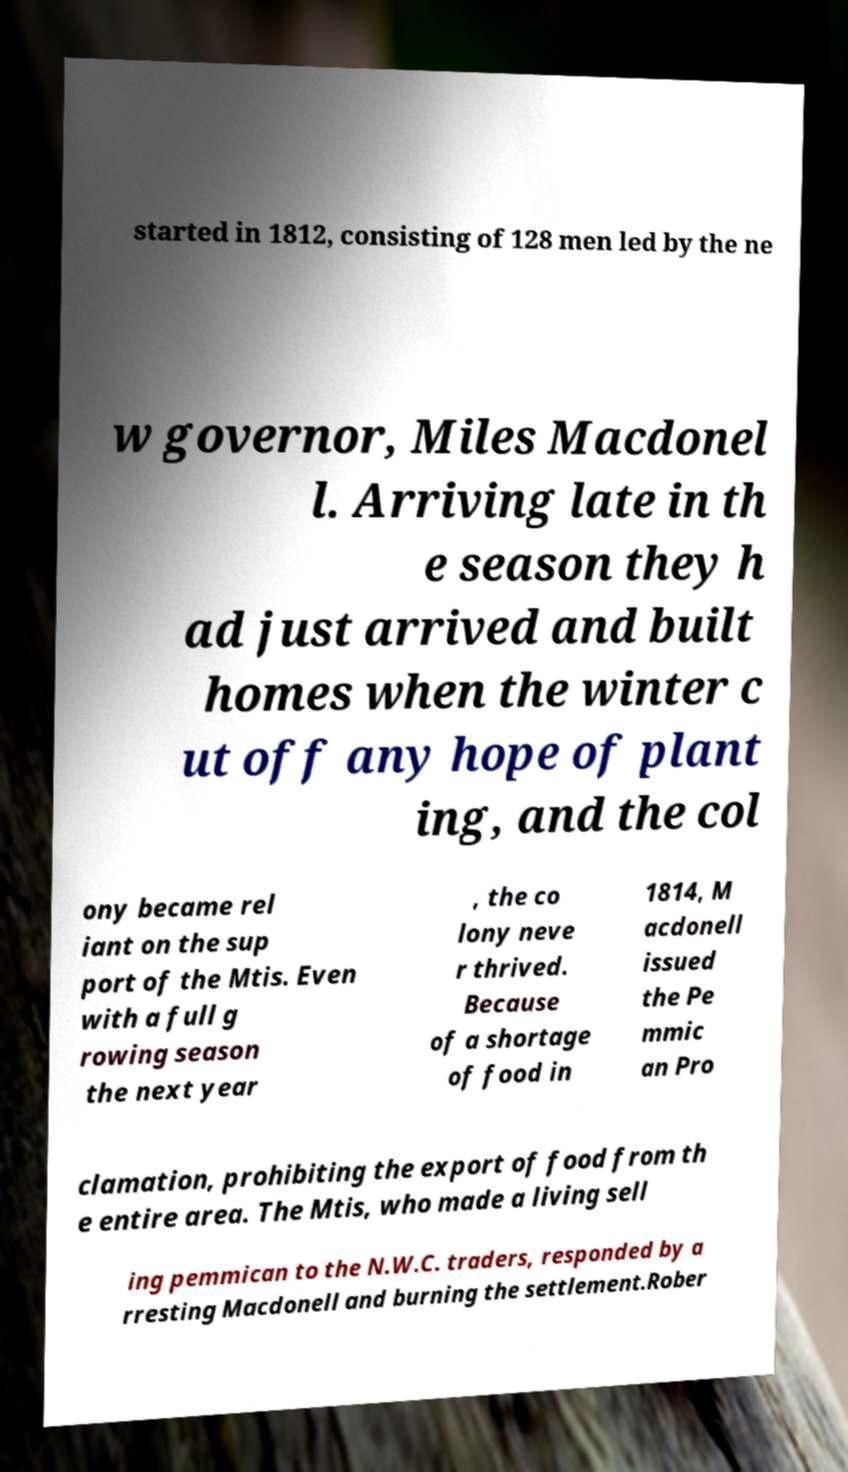Could you assist in decoding the text presented in this image and type it out clearly? started in 1812, consisting of 128 men led by the ne w governor, Miles Macdonel l. Arriving late in th e season they h ad just arrived and built homes when the winter c ut off any hope of plant ing, and the col ony became rel iant on the sup port of the Mtis. Even with a full g rowing season the next year , the co lony neve r thrived. Because of a shortage of food in 1814, M acdonell issued the Pe mmic an Pro clamation, prohibiting the export of food from th e entire area. The Mtis, who made a living sell ing pemmican to the N.W.C. traders, responded by a rresting Macdonell and burning the settlement.Rober 